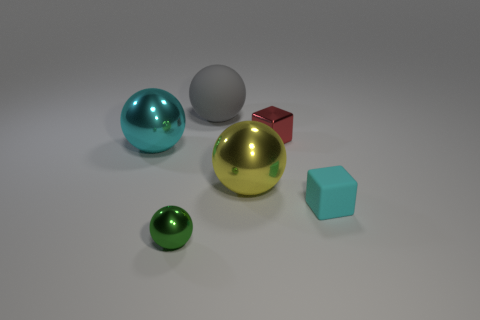What shape is the big metal object that is the same color as the small matte thing?
Your response must be concise. Sphere. Is the color of the tiny block in front of the large cyan metal ball the same as the shiny ball left of the green thing?
Give a very brief answer. Yes. Are there more small red shiny cubes left of the tiny matte block than small blue matte things?
Your response must be concise. Yes. What material is the big cyan object?
Offer a terse response. Metal. There is a cyan thing that is made of the same material as the small green thing; what shape is it?
Offer a terse response. Sphere. How big is the rubber thing right of the matte object behind the tiny red metal block?
Provide a succinct answer. Small. What color is the small metallic object behind the yellow metal ball?
Provide a succinct answer. Red. Are there any small cyan things of the same shape as the gray object?
Your answer should be very brief. No. Are there fewer cyan metallic balls that are behind the small red thing than metallic balls to the left of the big rubber thing?
Make the answer very short. Yes. What is the color of the rubber block?
Your answer should be compact. Cyan. 